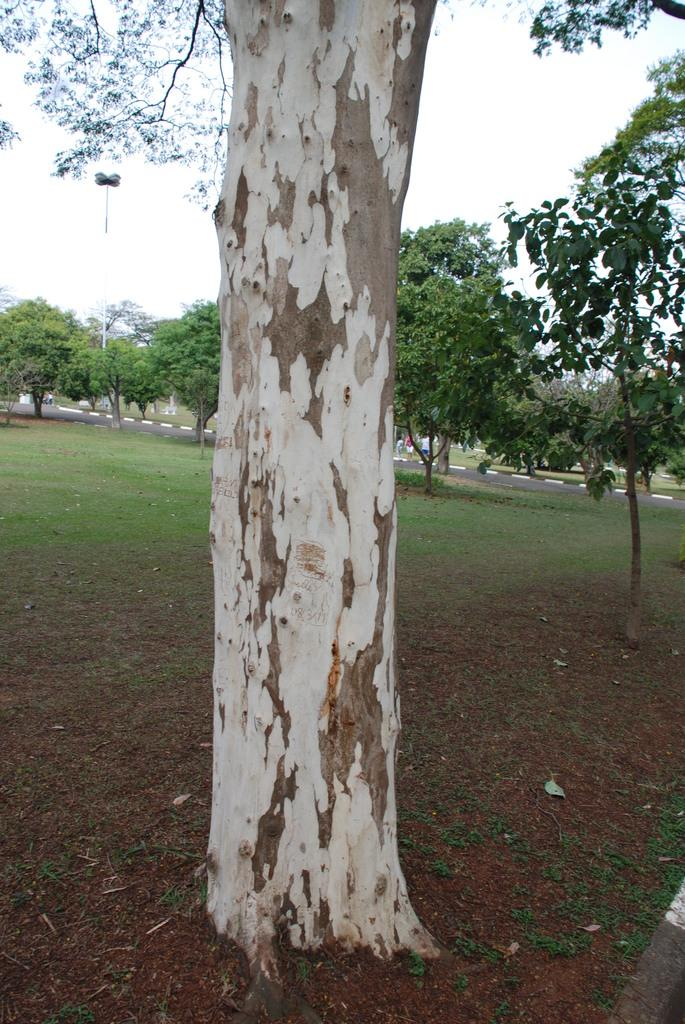What type of vegetation is present in the image? There are many trees, plants, and grass in the image. Can you describe the natural elements in the image? The image features trees, plants, grass, and the sky. Where is the sky visible in the image? The sky is visible in the top right of the image. What man-made object can be seen in the top left of the image? There is a street light in the top left of the image. What type of stitch is used to sew the trees together in the image? There is no stitching or sewing involved in the image; the trees are natural vegetation. What type of humor can be found in the image? The image does not contain any humor or comedic elements. 